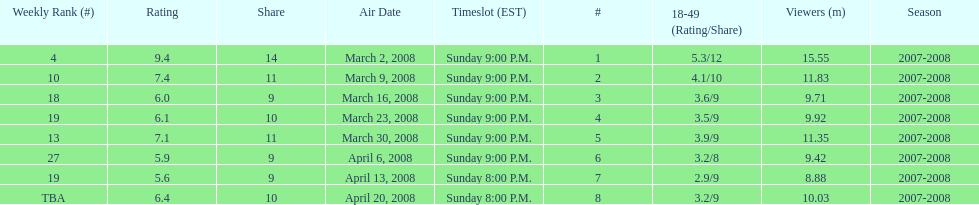Which show had the highest rating? 1. 